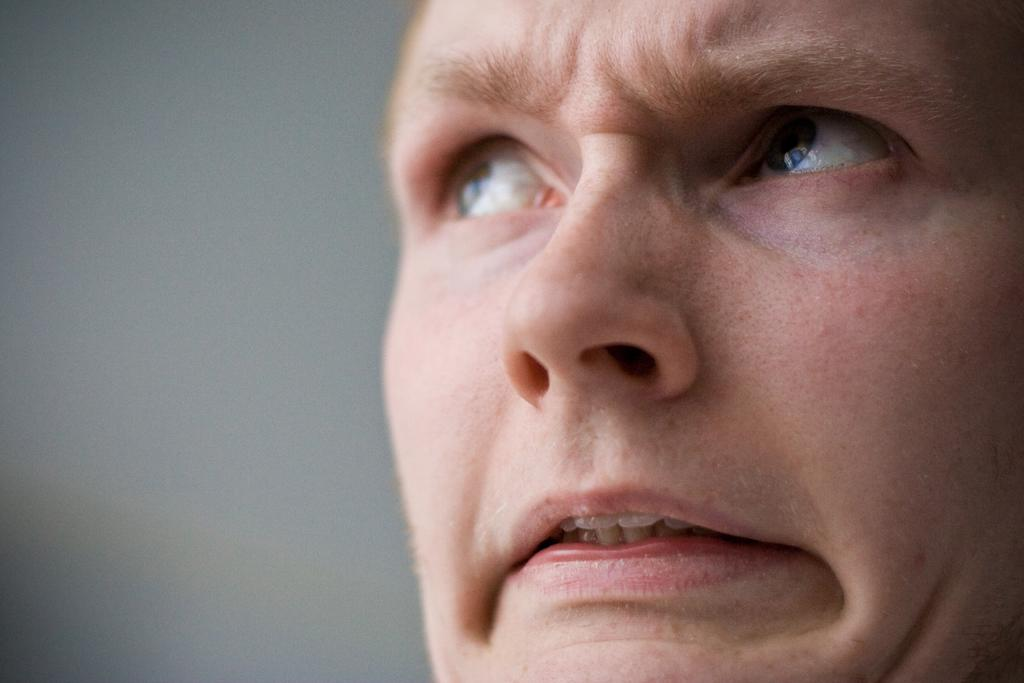Who is the main subject in the image? There is a man in the middle of the image. What is the man doing in the image? The man is staring at something. What can be seen in the background of the image? There is a wall in the background of the image. What type of machine is the man operating in the image? There is no machine present in the image; the man is simply staring at something. Does the man have wings in the image? No, the man does not have wings in the image. 